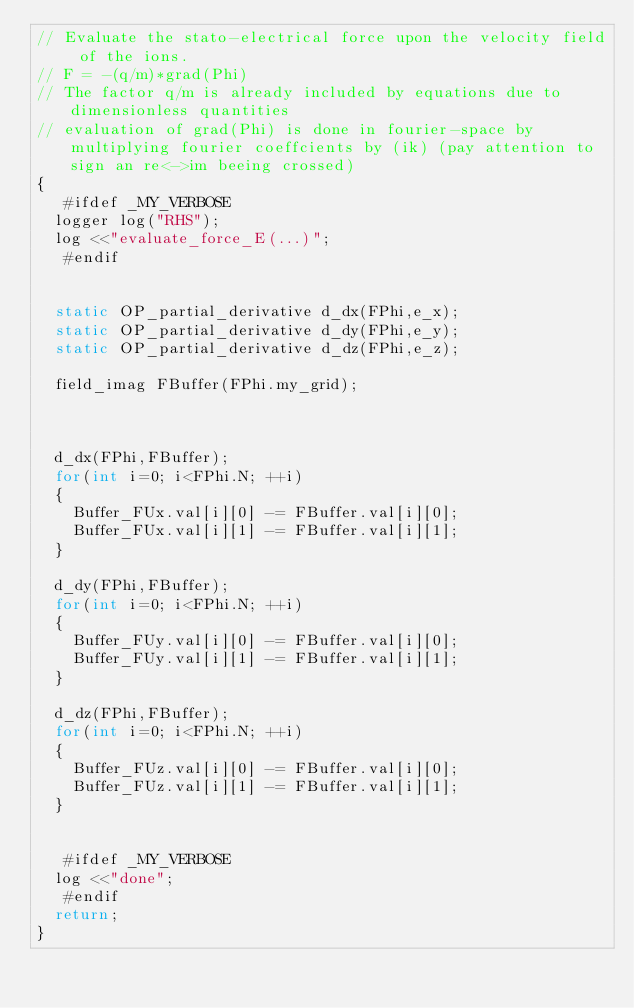Convert code to text. <code><loc_0><loc_0><loc_500><loc_500><_C++_>// Evaluate the stato-electrical force upon the velocity field of the ions.
// F = -(q/m)*grad(Phi)
// The factor q/m is already included by equations due to dimensionless quantities
// evaluation of grad(Phi) is done in fourier-space by multiplying fourier coeffcients by (ik) (pay attention to sign an re<->im beeing crossed)
{
   #ifdef _MY_VERBOSE
	logger log("RHS");
	log <<"evaluate_force_E(...)";
   #endif


	static OP_partial_derivative d_dx(FPhi,e_x);
	static OP_partial_derivative d_dy(FPhi,e_y);
	static OP_partial_derivative d_dz(FPhi,e_z);

	field_imag FBuffer(FPhi.my_grid);



	d_dx(FPhi,FBuffer);
	for(int i=0; i<FPhi.N; ++i)
	{
		Buffer_FUx.val[i][0] -= FBuffer.val[i][0];
		Buffer_FUx.val[i][1] -= FBuffer.val[i][1];
	}

	d_dy(FPhi,FBuffer);
	for(int i=0; i<FPhi.N; ++i)
	{
		Buffer_FUy.val[i][0] -= FBuffer.val[i][0];
		Buffer_FUy.val[i][1] -= FBuffer.val[i][1];
	}

	d_dz(FPhi,FBuffer);
	for(int i=0; i<FPhi.N; ++i)
	{
		Buffer_FUz.val[i][0] -= FBuffer.val[i][0];
		Buffer_FUz.val[i][1] -= FBuffer.val[i][1];
	}


   #ifdef _MY_VERBOSE
	log <<"done";
   #endif
	return;
}
</code> 